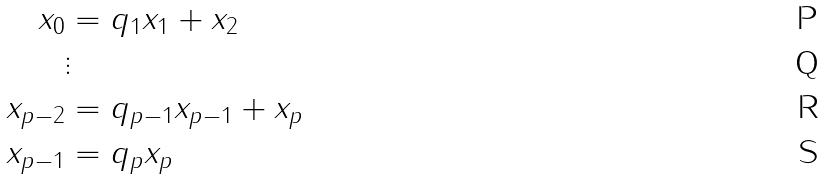Convert formula to latex. <formula><loc_0><loc_0><loc_500><loc_500>x _ { 0 } & = q _ { 1 } x _ { 1 } + x _ { 2 } \\ & \vdots \\ x _ { p - 2 } & = q _ { p - 1 } x _ { p - 1 } + x _ { p } \\ x _ { p - 1 } & = q _ { p } x _ { p }</formula> 